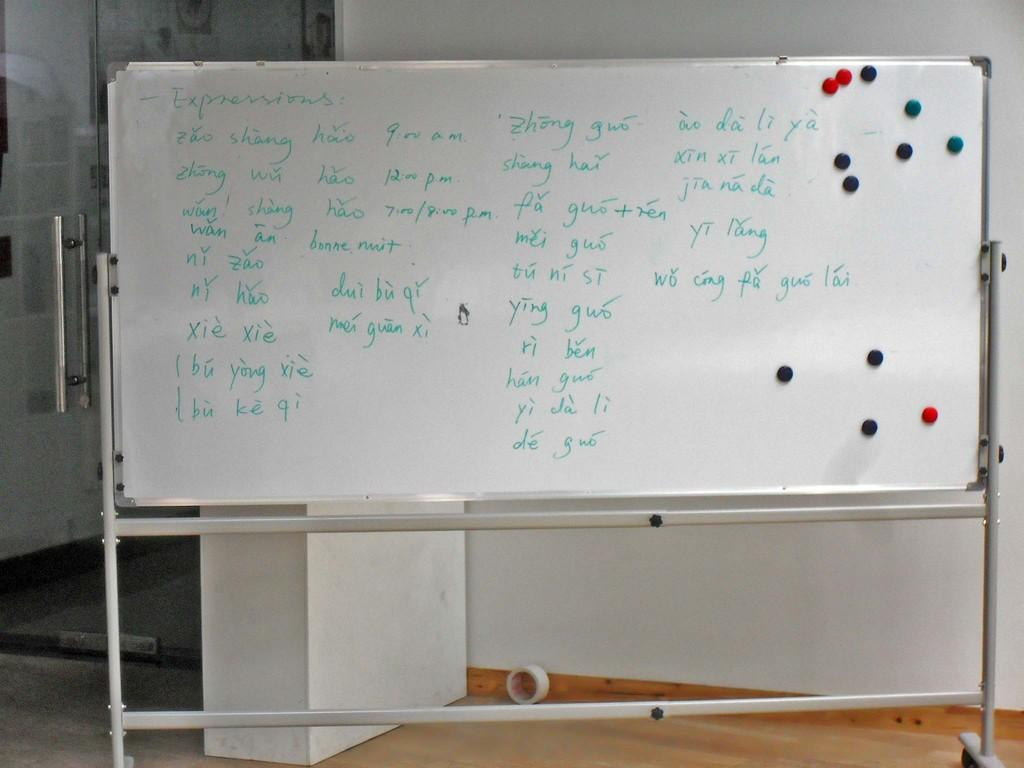Provide a one-sentence caption for the provided image. A white board with various expressions in a foreign language, and times ranging from 9 am to 8 pm written on it. 